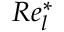Convert formula to latex. <formula><loc_0><loc_0><loc_500><loc_500>R e _ { l } ^ { \ast }</formula> 